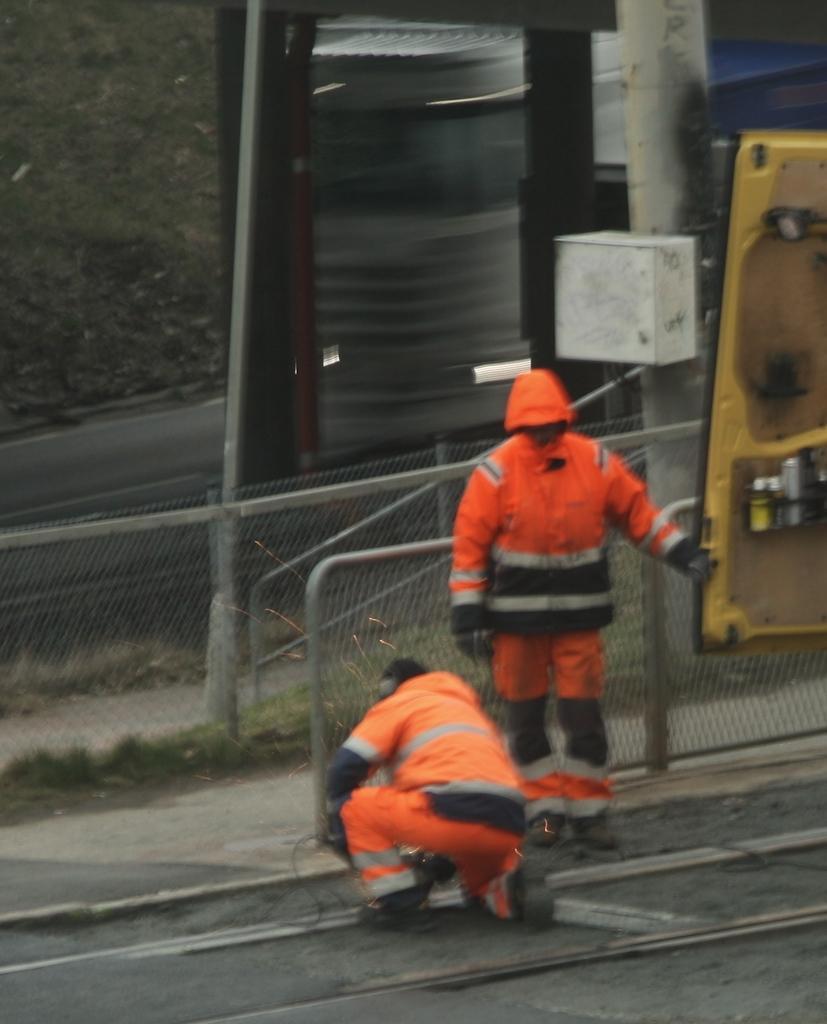Could you give a brief overview of what you see in this image? In this picture I can see the tracks in front on which there are 2 persons who are wearing same dress and in the background I see the fencing and I see a yellow color thing on the right side of this picture and I see a pole behind these people on which there is a white color box. 